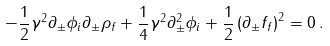Convert formula to latex. <formula><loc_0><loc_0><loc_500><loc_500>- \frac { 1 } { 2 } \gamma ^ { 2 } \partial _ { \pm } \phi _ { i } \partial _ { \pm } \rho _ { f } + \frac { 1 } { 4 } \gamma ^ { 2 } \partial _ { \pm } ^ { 2 } \phi _ { i } + \frac { 1 } { 2 } \left ( \partial _ { \pm } { f } _ { f } \right ) ^ { 2 } = 0 \, .</formula> 